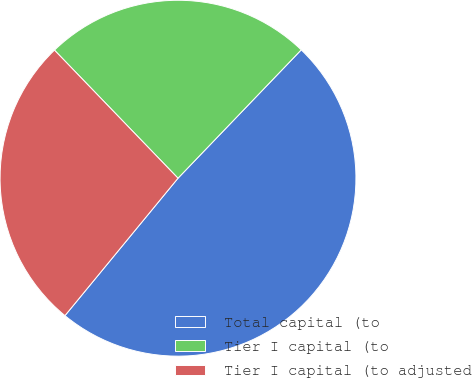<chart> <loc_0><loc_0><loc_500><loc_500><pie_chart><fcel>Total capital (to<fcel>Tier I capital (to<fcel>Tier I capital (to adjusted<nl><fcel>48.78%<fcel>24.39%<fcel>26.83%<nl></chart> 